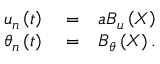Convert formula to latex. <formula><loc_0><loc_0><loc_500><loc_500>\begin{array} { r l r } { { { u } _ { n } } \left ( t \right ) } & = } & { a { { B } _ { u } } \left ( X \right ) } \\ { { { \theta } _ { n } } \left ( t \right ) } & = } & { { { B } _ { \theta } } \left ( X \right ) . } \end{array}</formula> 